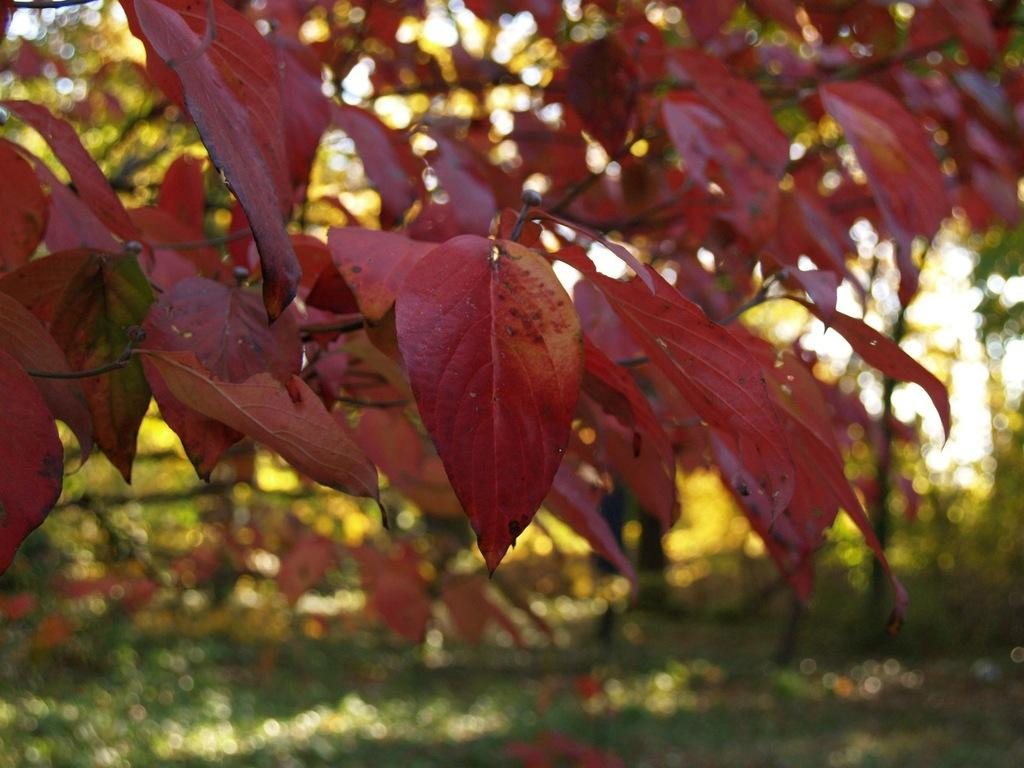What type of natural elements can be seen in the image? There are leaves of a tree in the image. Can you describe the leaves in the image? The leaves appear to be green and are likely from a deciduous tree. What might be the season based on the appearance of the leaves? The leaves appear to be green, which suggests that it is either spring or summer. What type of bridge can be seen in the image? There is no bridge present in the image; it only features leaves of a tree. 